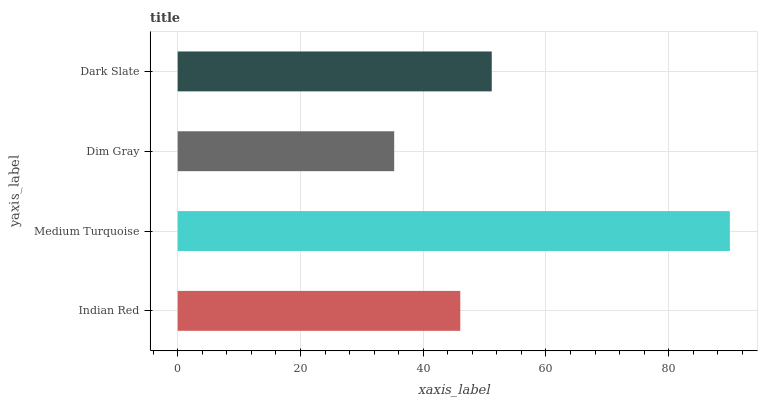Is Dim Gray the minimum?
Answer yes or no. Yes. Is Medium Turquoise the maximum?
Answer yes or no. Yes. Is Medium Turquoise the minimum?
Answer yes or no. No. Is Dim Gray the maximum?
Answer yes or no. No. Is Medium Turquoise greater than Dim Gray?
Answer yes or no. Yes. Is Dim Gray less than Medium Turquoise?
Answer yes or no. Yes. Is Dim Gray greater than Medium Turquoise?
Answer yes or no. No. Is Medium Turquoise less than Dim Gray?
Answer yes or no. No. Is Dark Slate the high median?
Answer yes or no. Yes. Is Indian Red the low median?
Answer yes or no. Yes. Is Medium Turquoise the high median?
Answer yes or no. No. Is Medium Turquoise the low median?
Answer yes or no. No. 